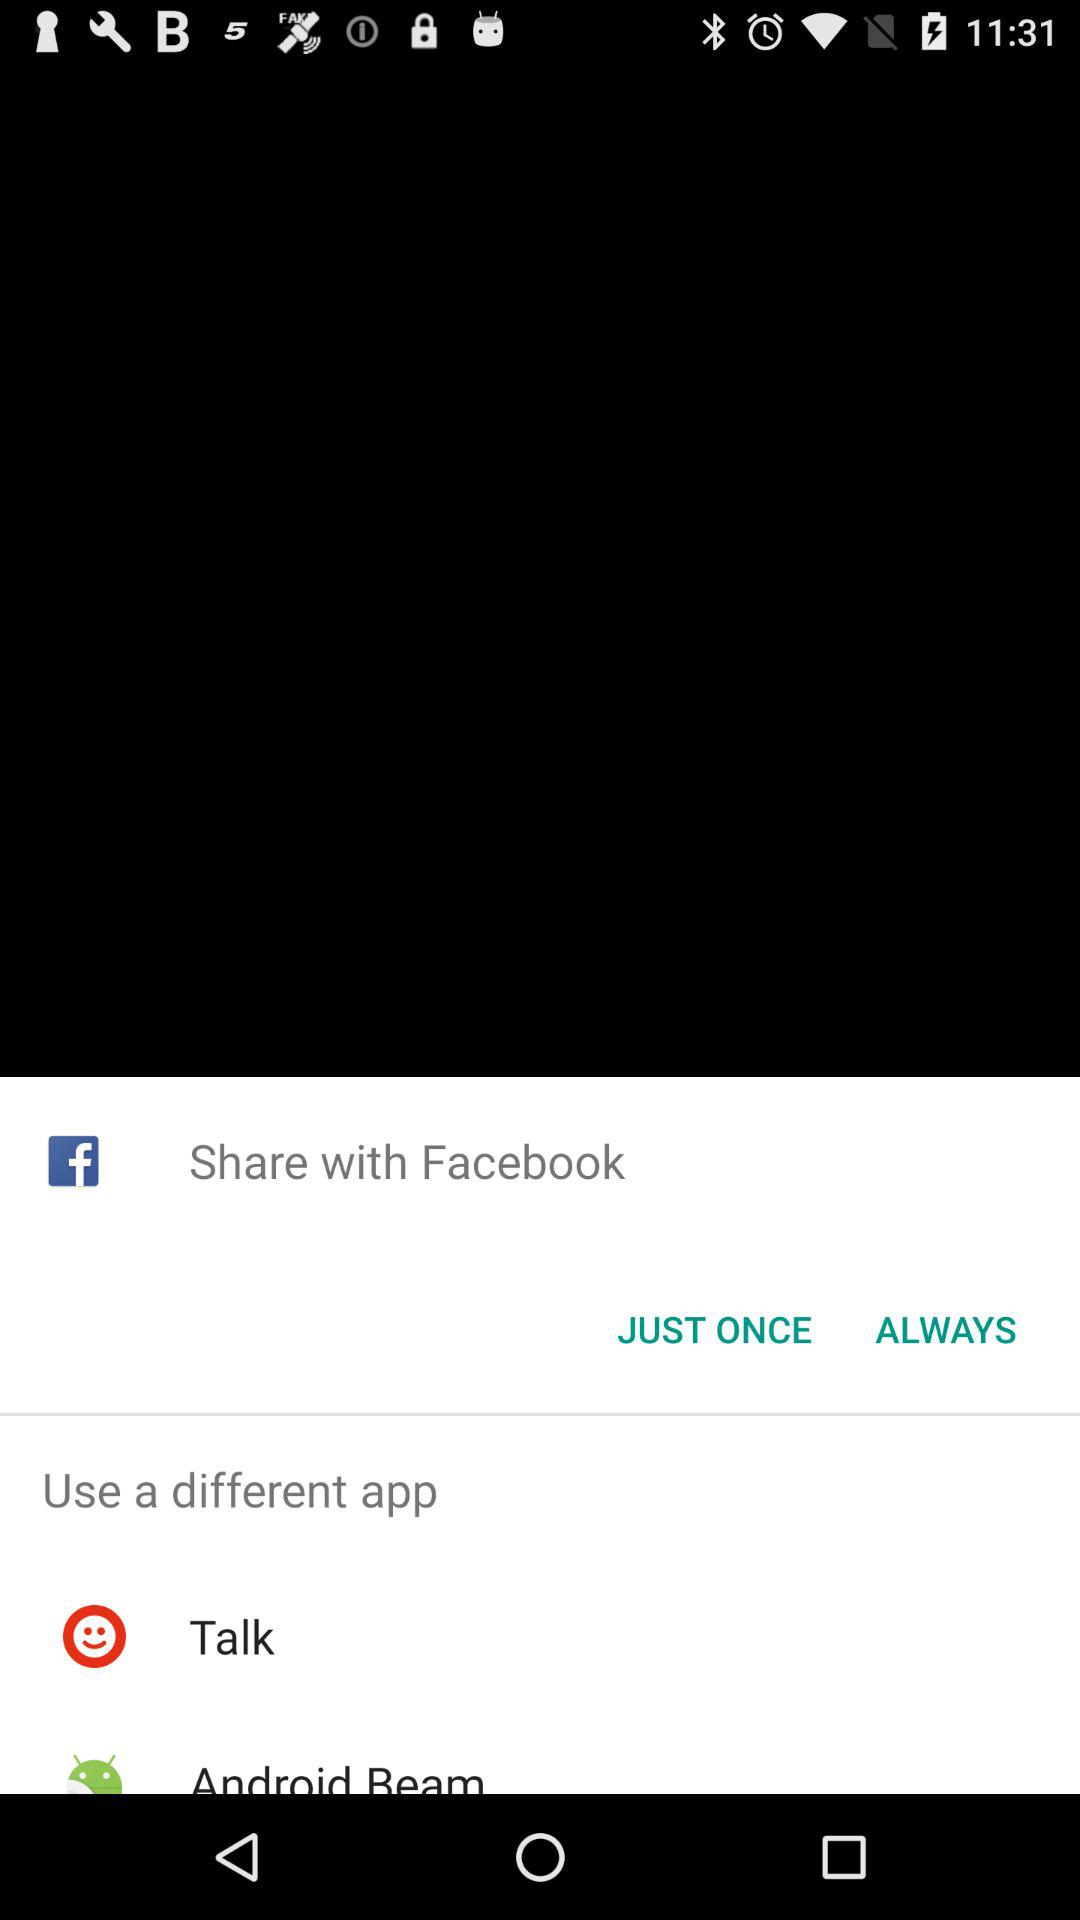Which applications can we use to share? You can share with "Facebook", "Talk" and "Android Beam". 